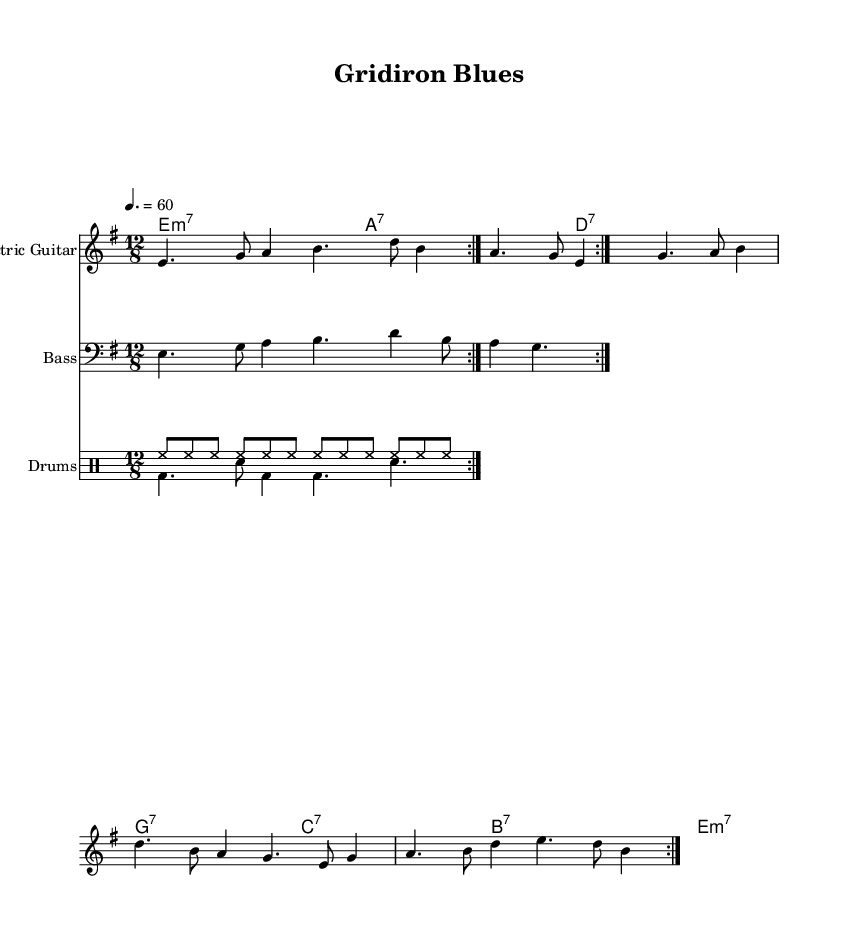What key signature does this music have? The key signature is E minor, which has one sharp (F#). This can be identified by looking for the key signature indicated at the beginning of the staff where it shows one sharp.
Answer: E minor What is the time signature of this piece? The time signature is 12/8, which means there are 12 eighth notes in each measure. It is found directly following the key signature at the beginning of the score.
Answer: 12/8 What is the tempo marking for this song? The tempo marking indicates a speed of 60 beats per minute. This is stated at the beginning of the score, near the time signature.
Answer: 60 How many measures are repeated in the electric guitar section? The electric guitar section has a repeat marked with a volta indicating sections to play twice. This is indicated by the "repeat volta" instruction in the score, showing two iterations of the measures.
Answer: 2 What type of musical progression is predominantly used in the chord names? The chord progression used is based on minor and dominant seventh chords, typical for the Electric Blues style. This can be seen in the specific chords listed in the chord names section of the score.
Answer: Minor and dominant seventh What rhythmic pattern is present in the drums section? The drum pattern features a consistent hi-hat beat followed by a combination of bass drum and snare drum hits, typical for a slow, gritty blues. Looking at the drum notations reveals the alternating rhythms in both drum sections.
Answer: Hi-hat and bass/snare rhythm 